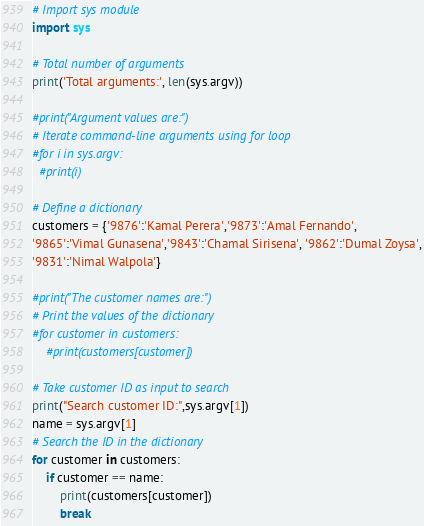Convert code to text. <code><loc_0><loc_0><loc_500><loc_500><_Python_># Import sys module
import sys

# Total number of arguments
print('Total arguments:', len(sys.argv))

#print("Argument values are:")
# Iterate command-line arguments using for loop
#for i in sys.argv:
  #print(i)

# Define a dictionary
customers = {'9876':'Kamal Perera','9873':'Amal Fernando',
'9865':'Vimal Gunasena','9843':'Chamal Sirisena', '9862':'Dumal Zoysa',
'9831':'Nimal Walpola'}

#print("The customer names are:")
# Print the values of the dictionary
#for customer in customers:
    #print(customers[customer])

# Take customer ID as input to search
print("Search customer ID:",sys.argv[1])
name = sys.argv[1]
# Search the ID in the dictionary
for customer in customers:
    if customer == name:
        print(customers[customer])
        break</code> 